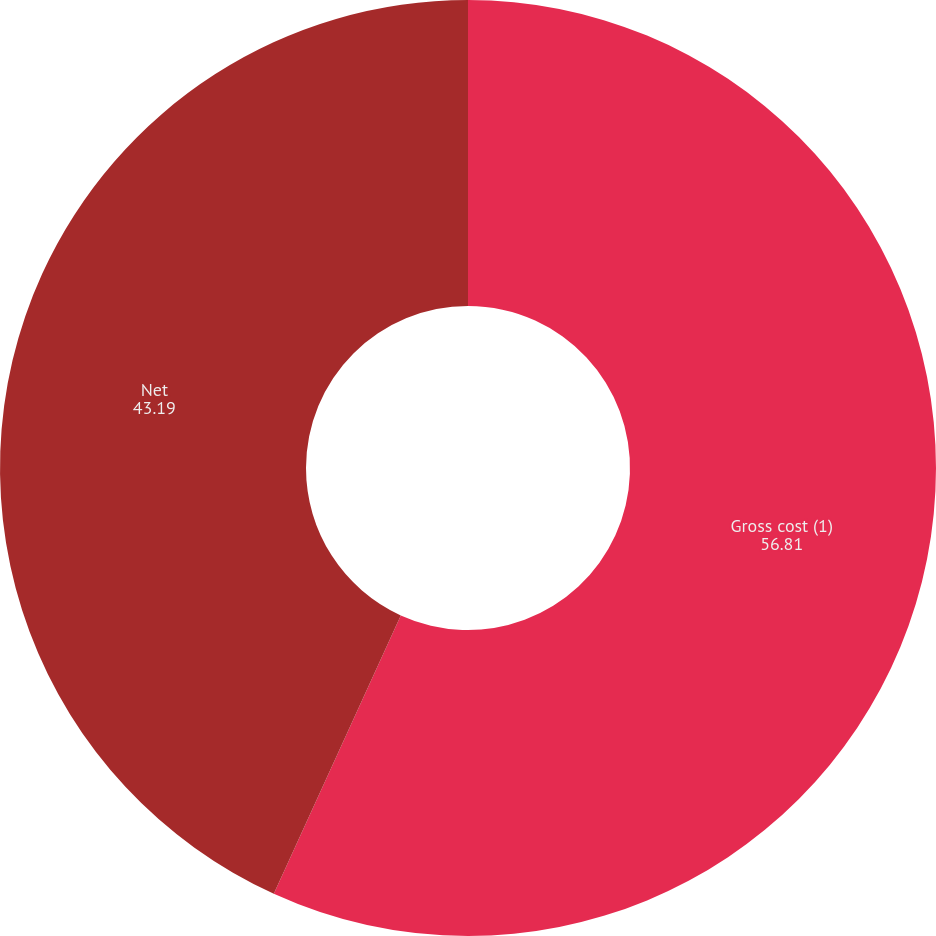Convert chart. <chart><loc_0><loc_0><loc_500><loc_500><pie_chart><fcel>Gross cost (1)<fcel>Net<nl><fcel>56.81%<fcel>43.19%<nl></chart> 